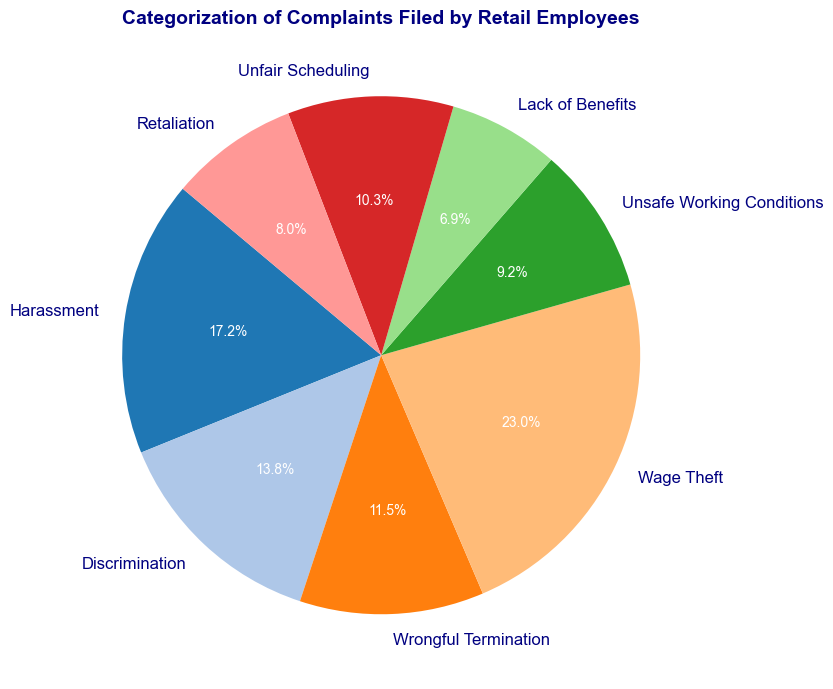What is the largest category of complaints filed by retail employees? The pie chart shows eight categories of complaints, with the largest section labeled "Wage Theft" at 200 complaints.
Answer: Wage Theft Which two categories of complaints together account for the highest percentage? First, identify the two largest sections in the pie chart: "Wage Theft" and "Harassment". Next, add their counts: 200 (Wage Theft) + 150 (Harassment) = 350 complaints. Verify the sum is the highest combination.
Answer: Wage Theft and Harassment What percentage of complaints are due to Unsafe Working Conditions? Locate the section labeled "Unsafe Working Conditions" in the pie chart. It shows a percentage of 9.3%.
Answer: 9.3% How does the number of Wage Theft complaints compare to Discrimination complaints? The number of Wage Theft complaints is 200, while the number of Discrimination complaints is 120. Comparatively, Wage Theft complaints are more.
Answer: Wage Theft complaints are more than Discrimination How many more Harassment complaints are there than Lack of Benefits complaints? According to the chart, Harassment complaints total 150, and Lack of Benefits complaints total 60. The difference is 150 - 60 = 90.
Answer: 90 complaints What is the combined percentage of Unfair Scheduling and Retaliation complaints? Locate the sections for "Unfair Scheduling" and "Retaliation". Unfair Scheduling has a percentage of 11.2%, and Retaliation has 8.7%. Combined, that is 11.2% + 8.7% = 19.9%.
Answer: 19.9% Which category has the least number of complaints, and what is that number? Find the smallest section in the chart, which is "Lack of Benefits" with 60 complaints.
Answer: Lack of Benefits, 60 complaints Are there more Discrimination complaints or Wrongful Termination complaints? Identify the counts for both categories from the chart. Discrimination has 120 complaints, and Wrongful Termination has 100 complaints. Discrimination has more.
Answer: Discrimination 